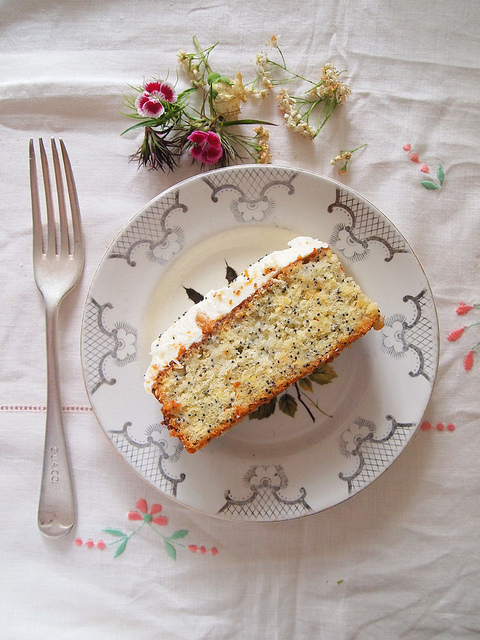Can you provide some background knowledge about such cakes and their typical occasions? Certainly! Cakes like the one depicted in the image, particularly those enhanced with frosting, are commonly associated with celebrations. While they are popularly linked with birthdays, these cakes also make appearances at a variety of other events such as anniversaries, weddings, and graduation parties. The inclusion of specific ingredients, like seeds or fruits, might suggest a particular variety or cultural significance. For instance, poppy seed cakes are cherished in certain European cultures, while fruit cakes are customary during specific holidays. The manner in which a cake is presented, often with decorative elements like flower arrangements, adds to the formality and significance of the occasion. 